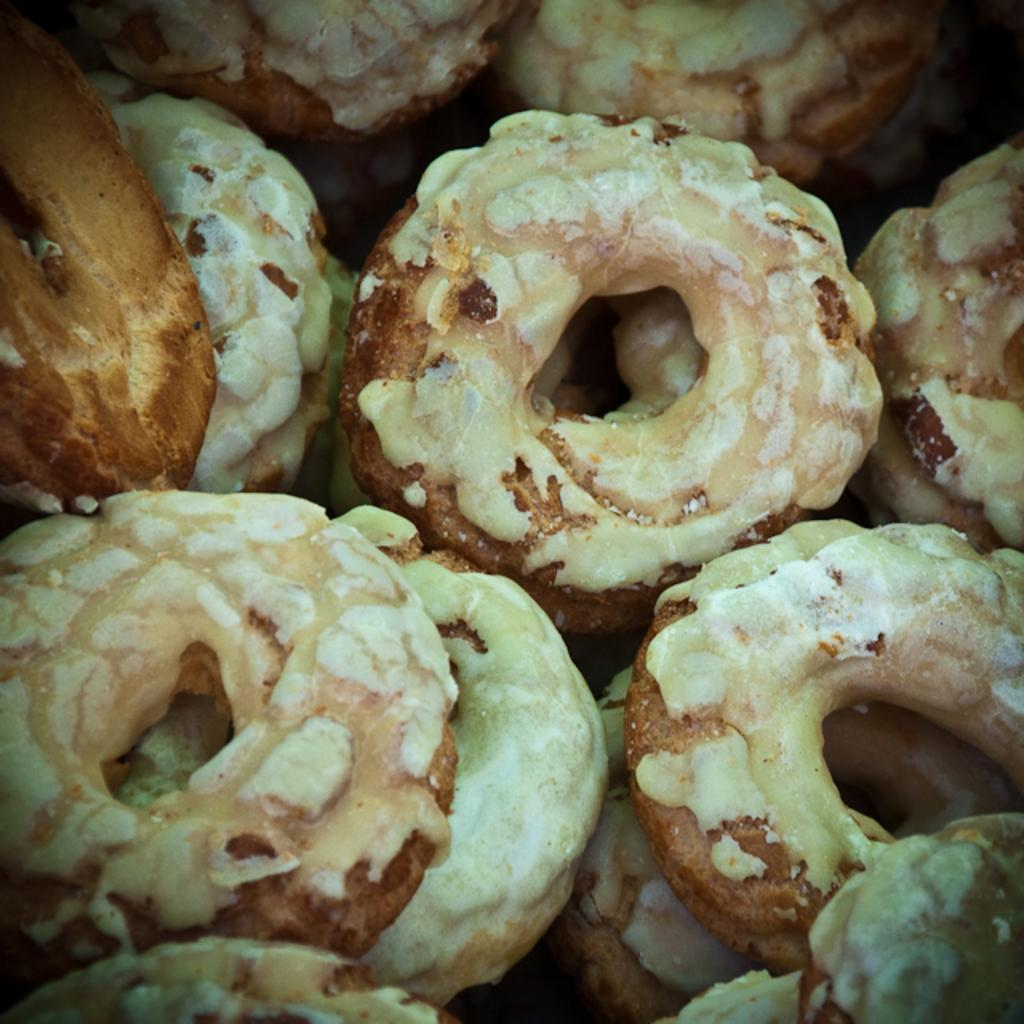What type of food is present in the image? There are doughnuts in the image. How many ladybugs are crawling on the doughnuts in the image? There are no ladybugs present in the image; it only features doughnuts. 